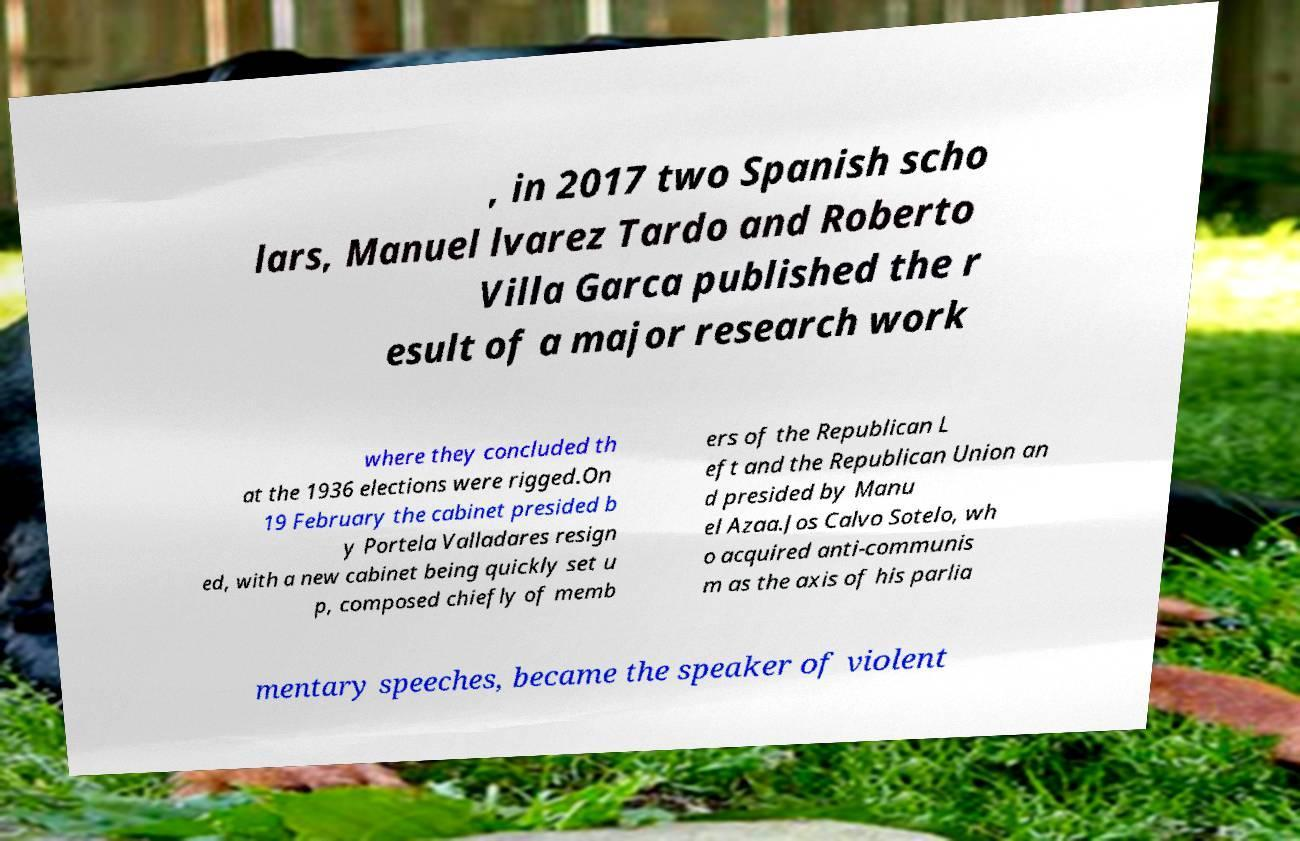For documentation purposes, I need the text within this image transcribed. Could you provide that? , in 2017 two Spanish scho lars, Manuel lvarez Tardo and Roberto Villa Garca published the r esult of a major research work where they concluded th at the 1936 elections were rigged.On 19 February the cabinet presided b y Portela Valladares resign ed, with a new cabinet being quickly set u p, composed chiefly of memb ers of the Republican L eft and the Republican Union an d presided by Manu el Azaa.Jos Calvo Sotelo, wh o acquired anti-communis m as the axis of his parlia mentary speeches, became the speaker of violent 